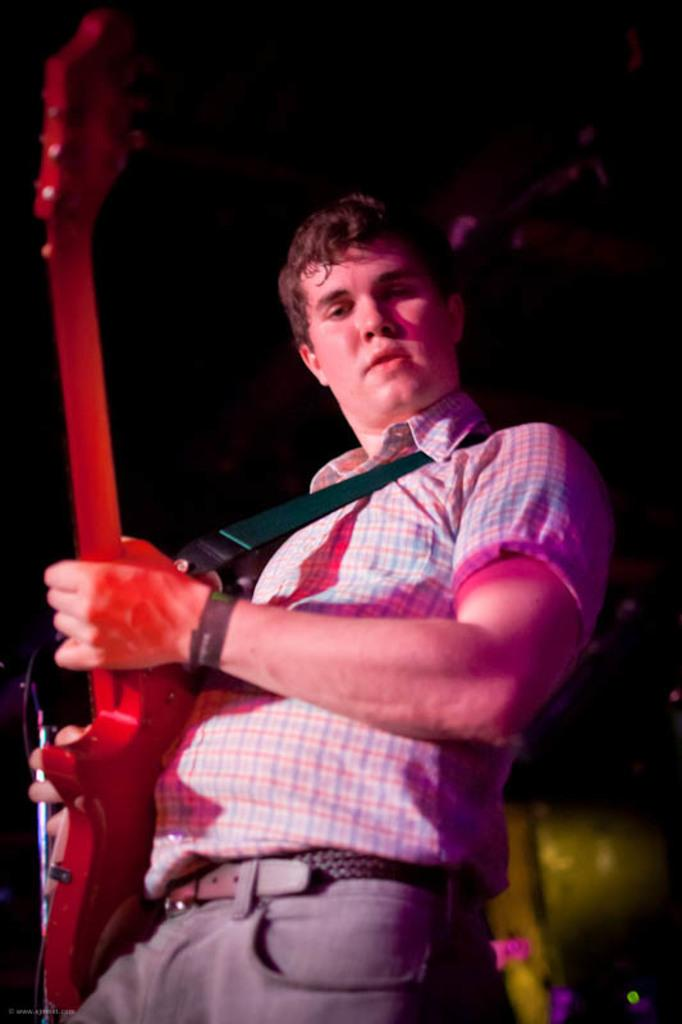Who or what is the main subject in the image? There is a person in the image. What is the person doing in the image? The person is playing a guitar. What type of list can be seen in the image? There is no list present in the image; it features a person playing a guitar. What channel is the person tuning in the image? There is no television or channel present in the image; it features a person playing a guitar. 